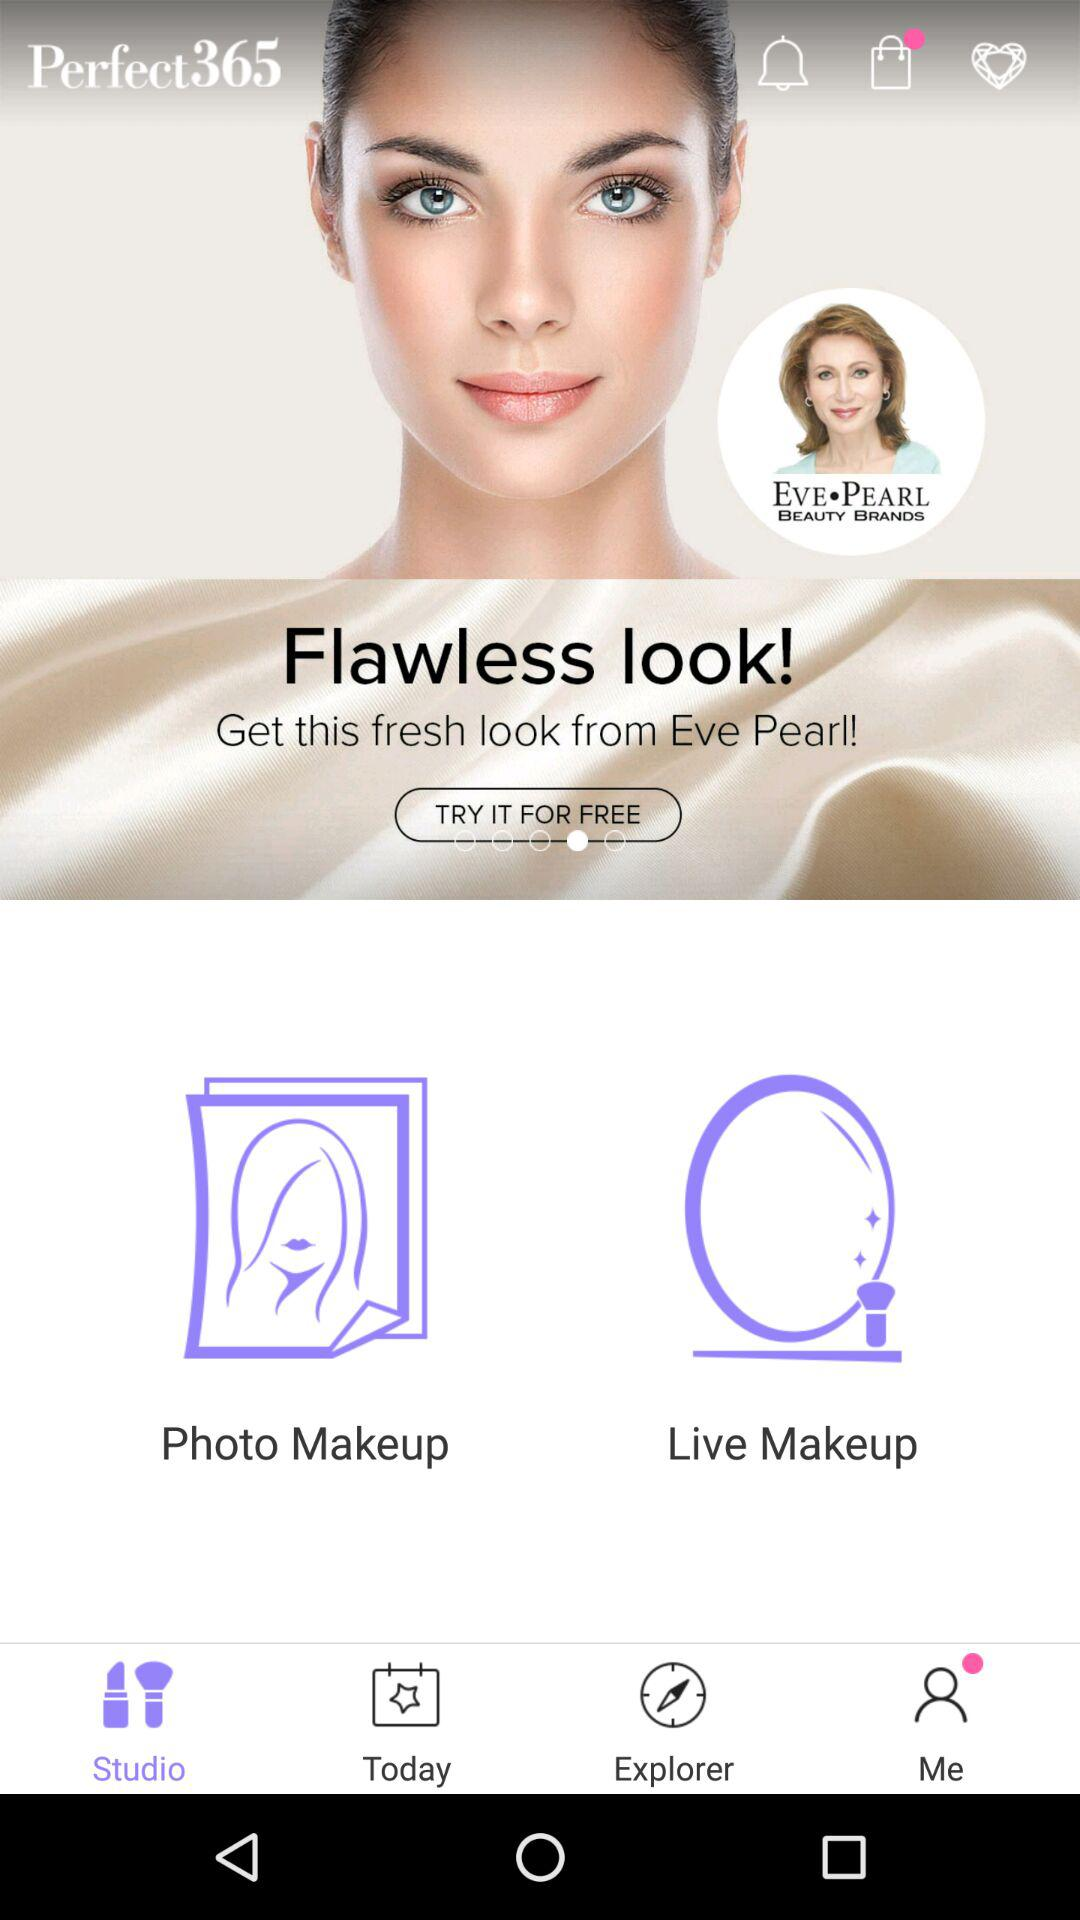Which tab is selected? The selected tab is "Studio". 